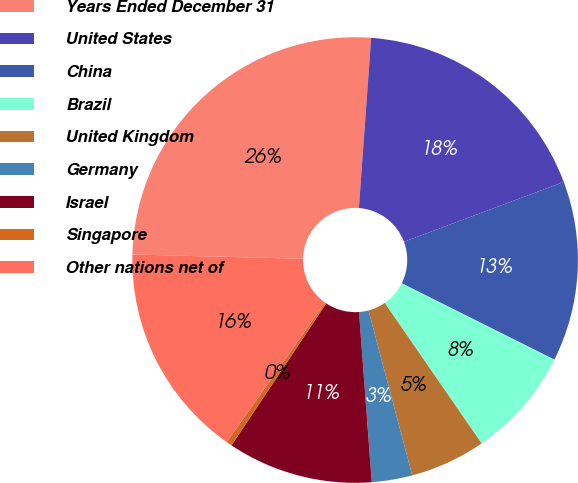<chart> <loc_0><loc_0><loc_500><loc_500><pie_chart><fcel>Years Ended December 31<fcel>United States<fcel>China<fcel>Brazil<fcel>United Kingdom<fcel>Germany<fcel>Israel<fcel>Singapore<fcel>Other nations net of<nl><fcel>25.75%<fcel>18.15%<fcel>13.08%<fcel>8.01%<fcel>5.48%<fcel>2.94%<fcel>10.55%<fcel>0.41%<fcel>15.62%<nl></chart> 